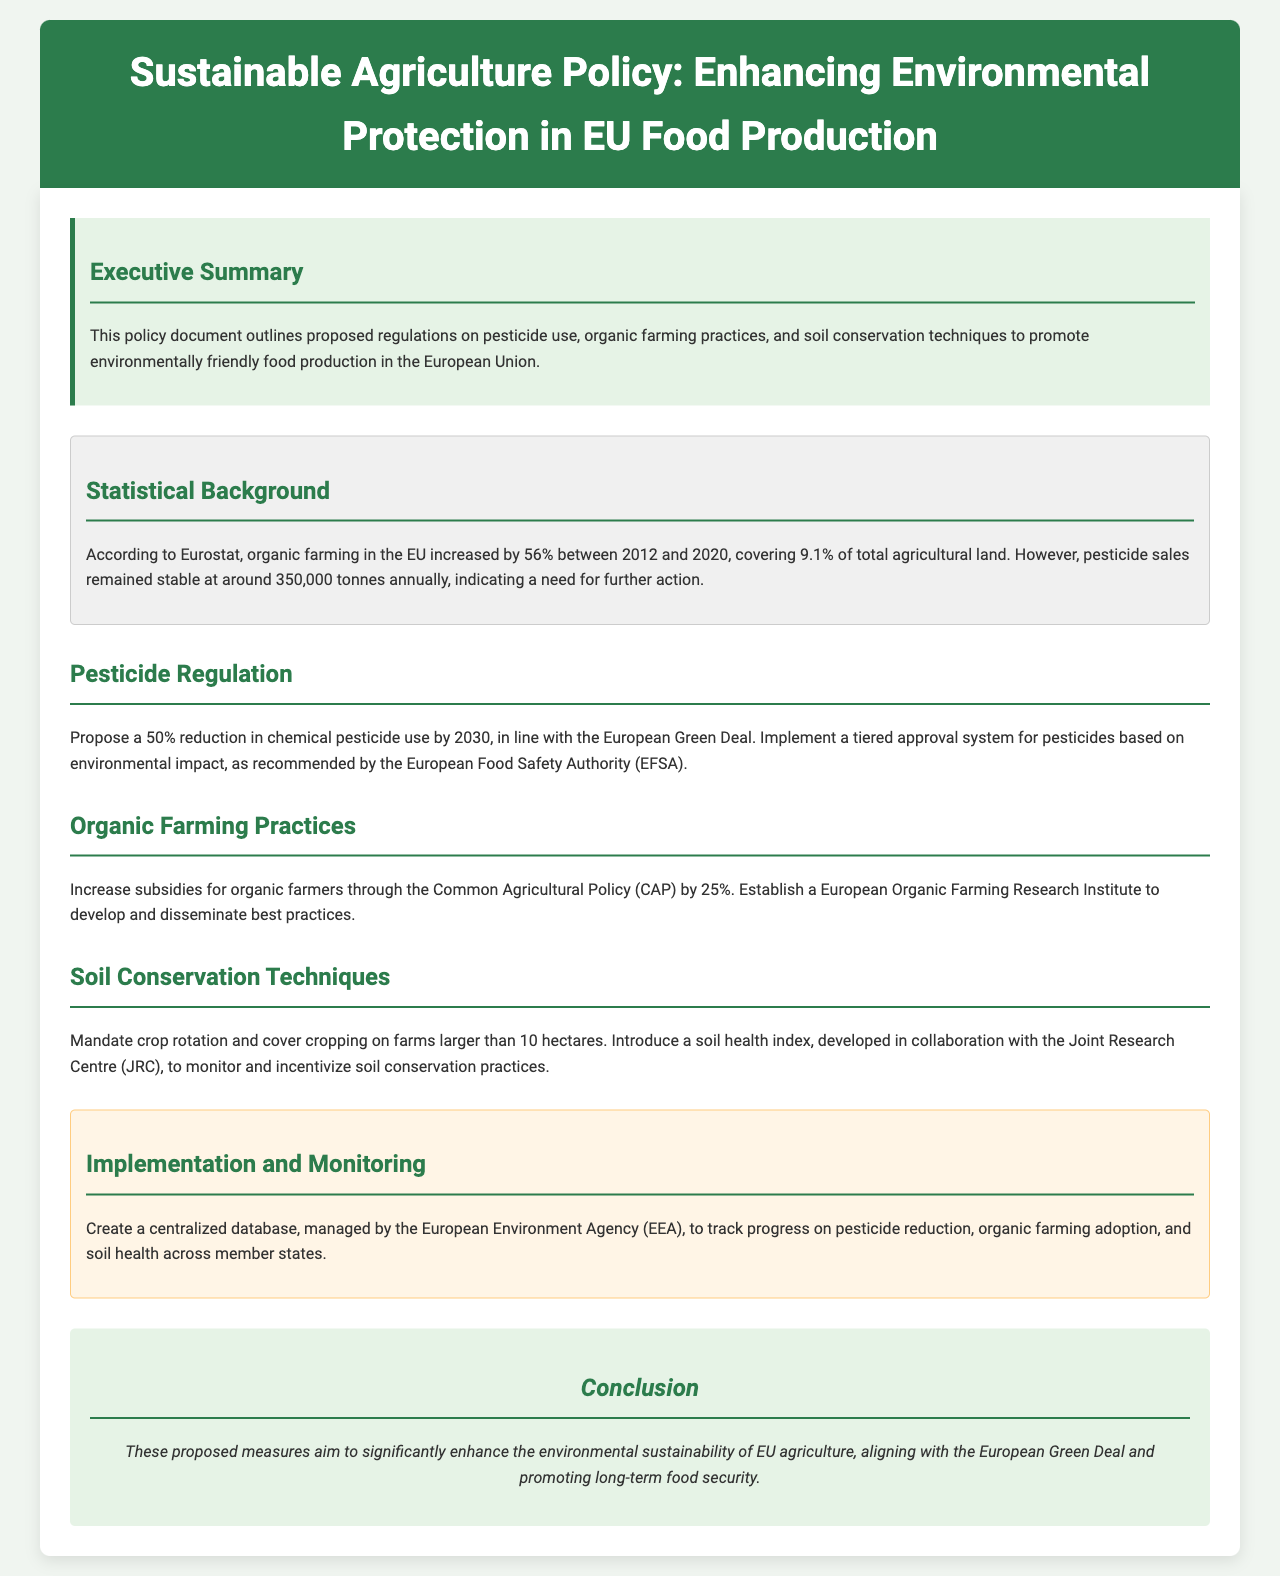what percentage increase in organic farming was observed between 2012 and 2020? The document states that organic farming in the EU increased by 56% during this period.
Answer: 56% how much agricultural land does organic farming cover in the EU? According to the document, organic farming covers 9.1% of total agricultural land in the EU.
Answer: 9.1% what is the proposed reduction in chemical pesticide use by 2030? The proposal states a 50% reduction in chemical pesticide use is aimed for by 2030.
Answer: 50% which authority recommends the tiered approval system for pesticides? The European Food Safety Authority (EFSA) is mentioned as the body recommending this system.
Answer: European Food Safety Authority (EFSA) what increase in subsidies for organic farmers is proposed through the Common Agricultural Policy? The document proposes a 25% increase in subsidies for organic farmers.
Answer: 25% what is one technique mandated for soil conservation on larger farms? The document mandates crop rotation as one technique for soil conservation on farms larger than 10 hectares.
Answer: Crop rotation what is the name of the proposed institute to support organic farming? The document mentions establishing a European Organic Farming Research Institute to support organic farming practices.
Answer: European Organic Farming Research Institute who is responsible for managing the centralized database for tracking agricultural practices? The document states that the European Environment Agency (EEA) will manage the centralized database.
Answer: European Environment Agency (EEA) what is the purpose of the introduced soil health index? The soil health index is introduced to monitor and incentivize soil conservation practices.
Answer: Monitor and incentivize soil conservation practices 